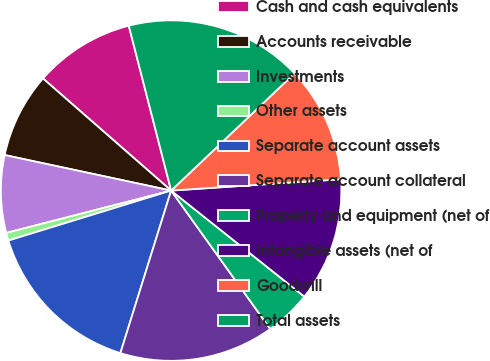Convert chart. <chart><loc_0><loc_0><loc_500><loc_500><pie_chart><fcel>Cash and cash equivalents<fcel>Accounts receivable<fcel>Investments<fcel>Other assets<fcel>Separate account assets<fcel>Separate account collateral<fcel>Property and equipment (net of<fcel>Intangible assets (net of<fcel>Goodwill<fcel>Total assets<nl><fcel>9.56%<fcel>8.09%<fcel>7.35%<fcel>0.74%<fcel>15.44%<fcel>14.71%<fcel>4.41%<fcel>11.76%<fcel>11.03%<fcel>16.91%<nl></chart> 